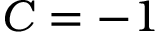Convert formula to latex. <formula><loc_0><loc_0><loc_500><loc_500>C = - 1</formula> 